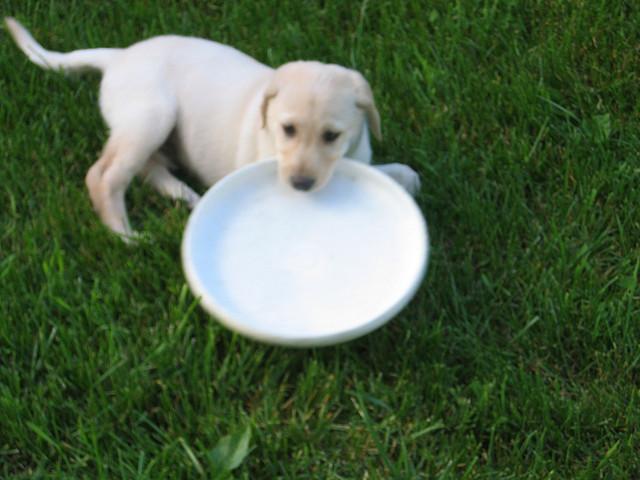What kind of dog is this?
Give a very brief answer. Lab. What type of dog is this?
Keep it brief. Lab. Is this an adult animal?
Be succinct. No. Is the dog playing?
Keep it brief. Yes. 